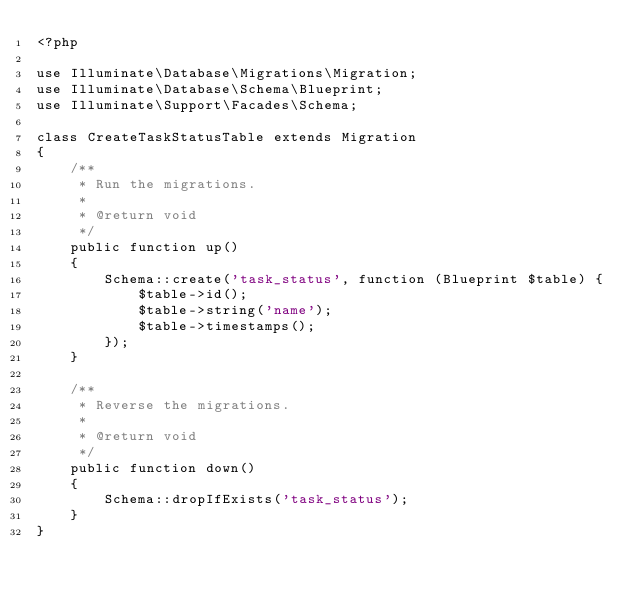Convert code to text. <code><loc_0><loc_0><loc_500><loc_500><_PHP_><?php

use Illuminate\Database\Migrations\Migration;
use Illuminate\Database\Schema\Blueprint;
use Illuminate\Support\Facades\Schema;

class CreateTaskStatusTable extends Migration
{
    /**
     * Run the migrations.
     *
     * @return void
     */
    public function up()
    {
        Schema::create('task_status', function (Blueprint $table) {
            $table->id();
            $table->string('name');
            $table->timestamps();
        });
    }

    /**
     * Reverse the migrations.
     *
     * @return void
     */
    public function down()
    {
        Schema::dropIfExists('task_status');
    }
}
</code> 